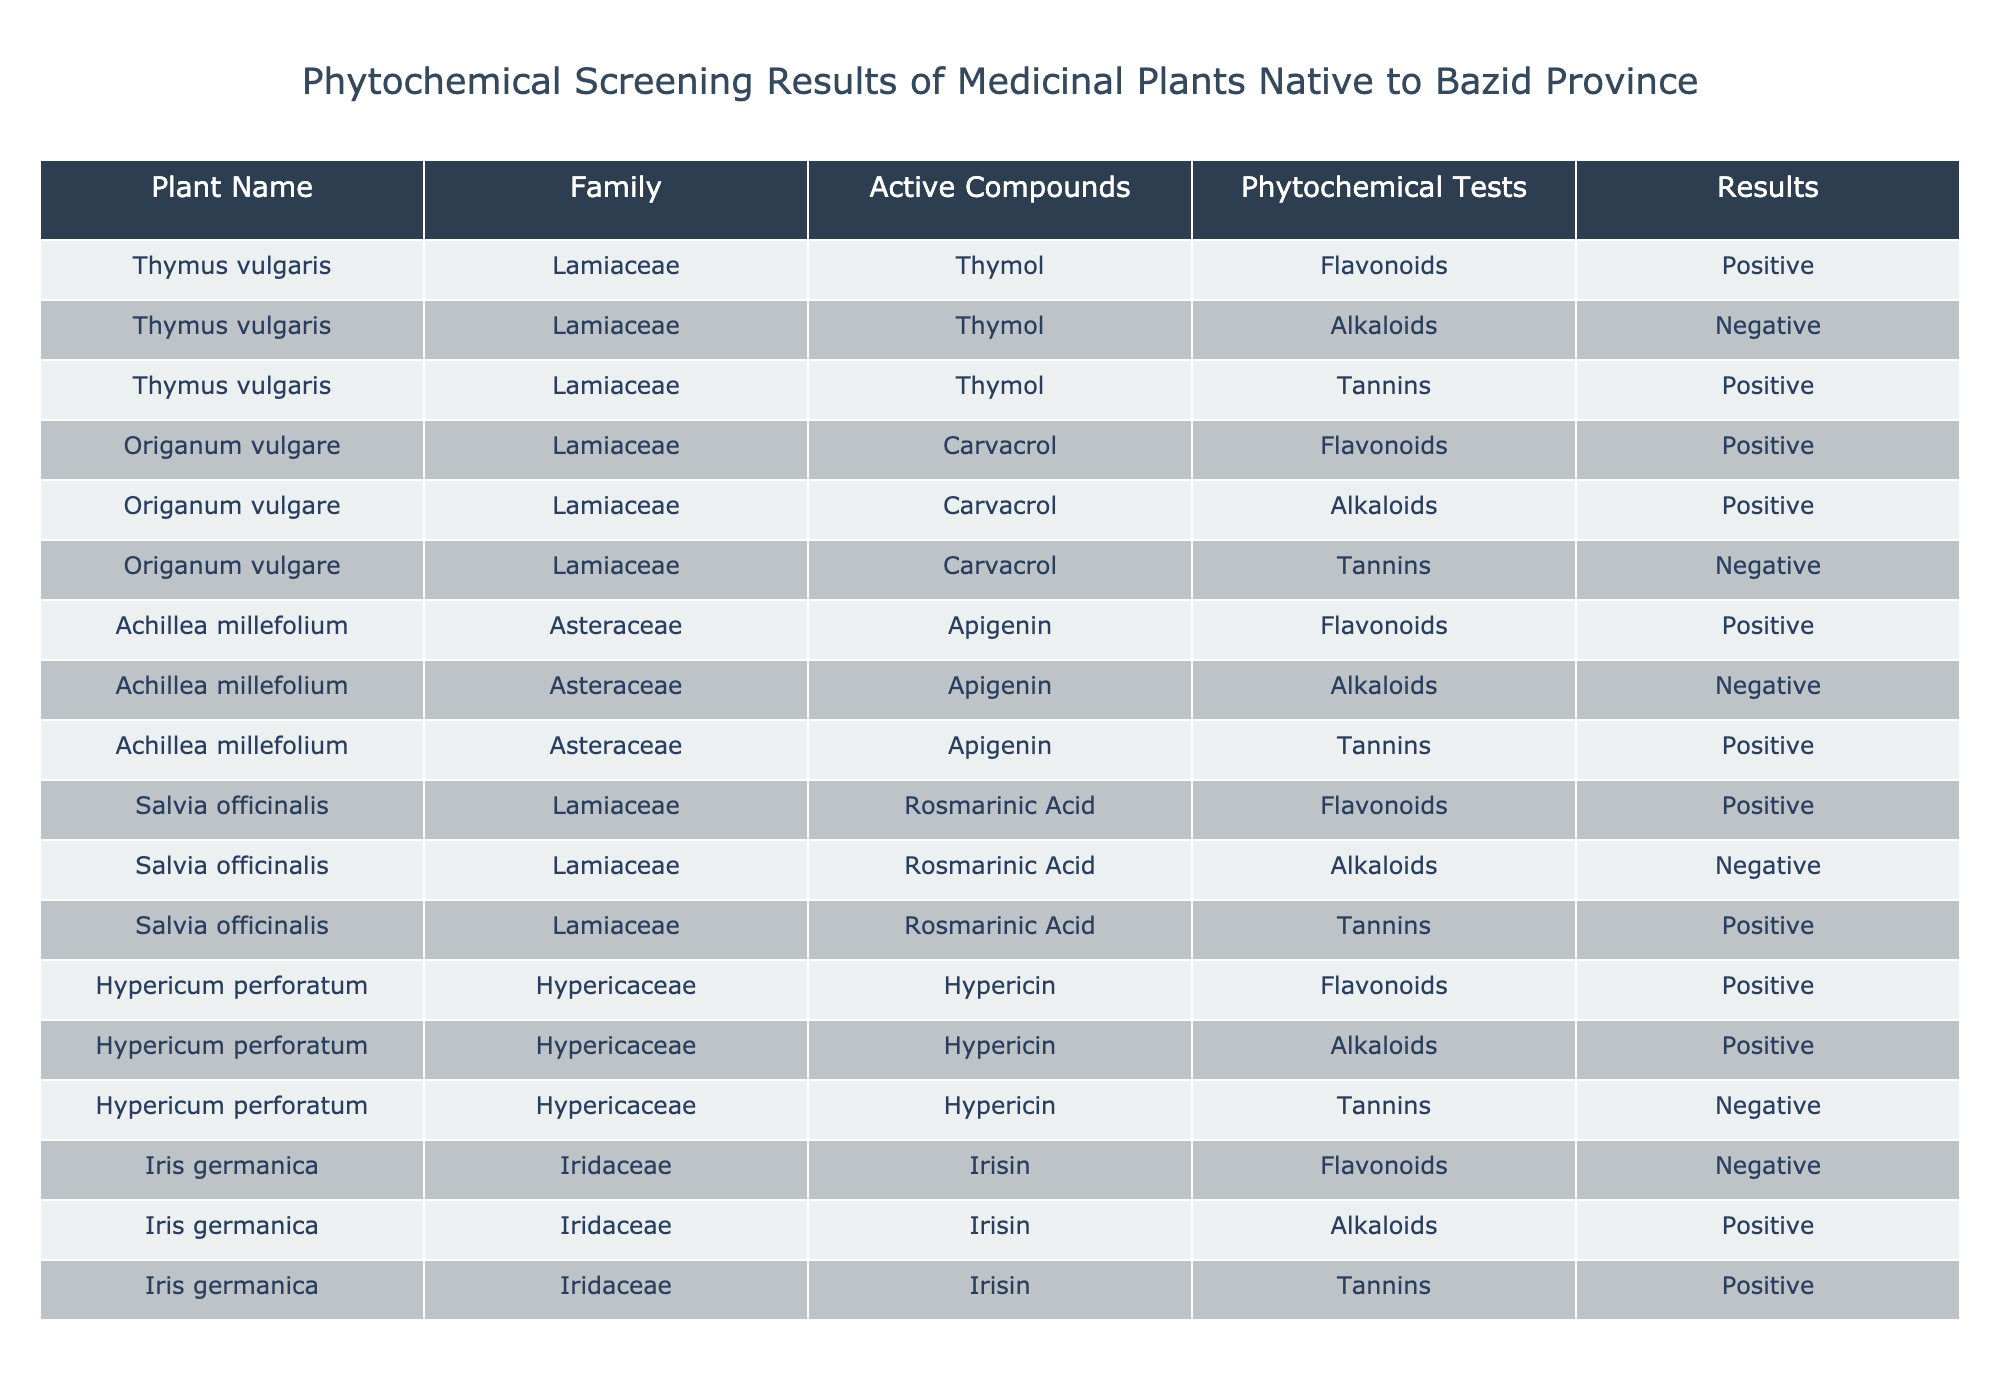What is the family of Thymus vulgaris? Thymus vulgaris belongs to the Lamiaceae family, as specified in the table under the Family column.
Answer: Lamiaceae Which plant contains the active compound Carvacrol? The plant Origanum vulgare contains the active compound Carvacrol, which is indicated in the Active Compounds column of the table.
Answer: Origanum vulgare How many plants tested positive for Alkaloids? Upon reviewing the table, only two plants tested positive for Alkaloids: Origanum vulgare and Iris germanica, according to the Results column.
Answer: 2 Is Achillea millefolium positive for Tannins? Yes, Achillea millefolium tests positive for Tannins, as stated in the Results column of the table.
Answer: Yes Which plant has the highest number of positive results across all phytochemical tests? To determine this, we count the total positive results for each plant. Thymus vulgaris, Origanum vulgare, Achillea millefolium, Salvia officinalis, and Hypericum perforatum each have 2 positive results but Iris germanica has 2 positive results as well, resulting in a tie at 2 positive results for each. However, none exceed this count.
Answer: All have 2 positive results How many total different active compounds are listed for the plants in the table? The active compounds listed for the plants include Thymol, Carvacrol, Apigenin, Rosmarinic Acid, and Hypericin, which totals to 5 unique active compounds.
Answer: 5 What is the result of Flavonoids in Iris germanica? The table clearly states that Iris germanica has a negative result for Flavonoids in the Results column.
Answer: Negative Which plant or plants have negative results for Tannins? From the table, only Hypericum perforatum has a negative result for Tannins, as indicated in the Results column.
Answer: Hypericum perforatum 